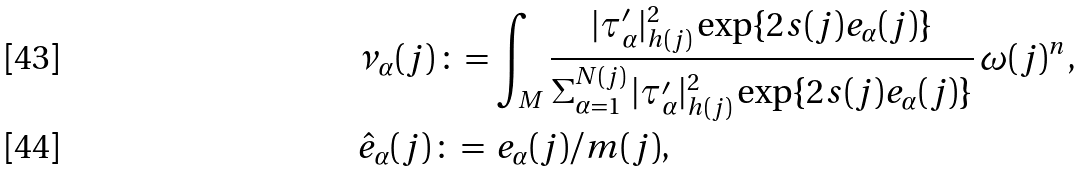Convert formula to latex. <formula><loc_0><loc_0><loc_500><loc_500>& \nu _ { \alpha } ( j ) \, \colon = \int _ { M } \frac { | \tau ^ { \prime } _ { \alpha } | ^ { 2 } _ { h ( j ) } \exp \{ 2 s ( j ) e _ { \alpha } ( j ) \} } { \Sigma _ { \alpha = 1 } ^ { N ( j ) } \, | \tau ^ { \prime } _ { \alpha } | ^ { 2 } _ { h ( j ) } \exp \{ 2 s ( j ) e _ { \alpha } ( j ) \} } \, \omega ( j ) ^ { n } , \\ & \hat { e } _ { \alpha } ( j ) \, \colon = \, e _ { \alpha } ( j ) / m ( j ) ,</formula> 